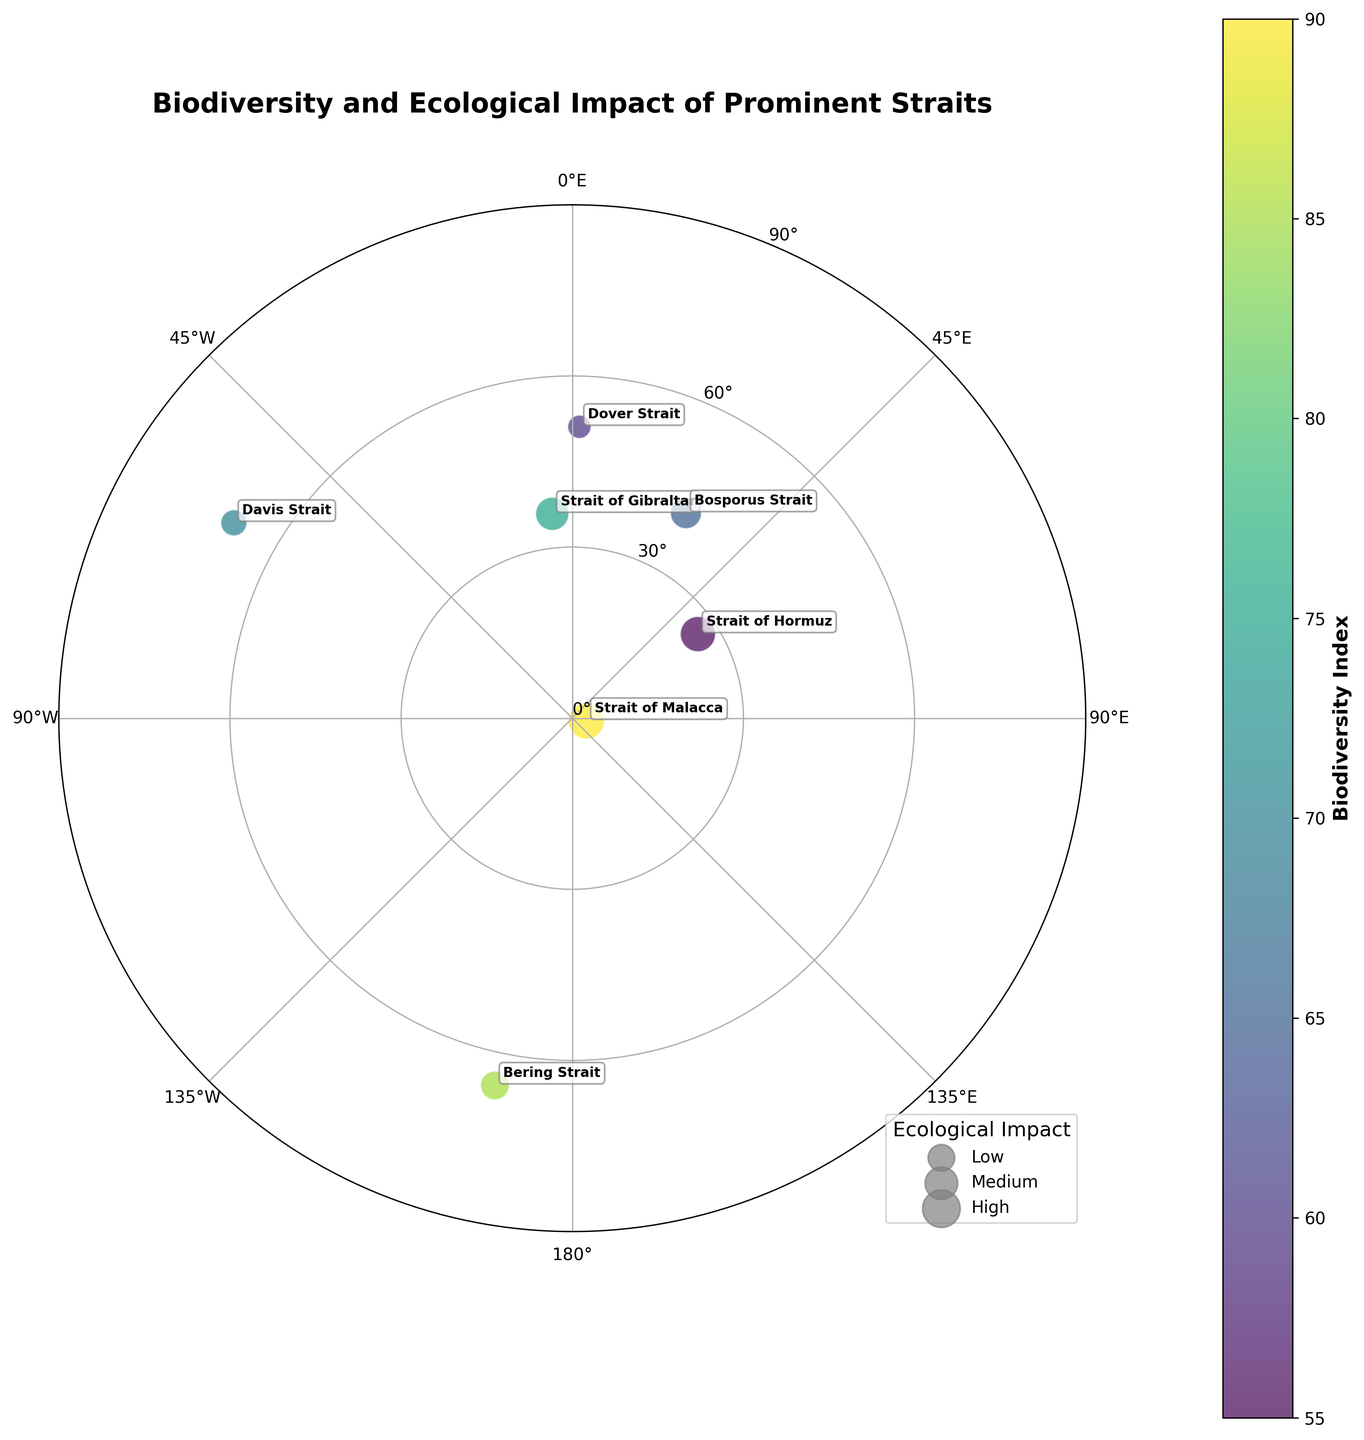What's the title of the figure? The title of the figure is displayed at the top, summarizing the main content it represents.
Answer: Biodiversity and Ecological Impact of Prominent Straits How many straits are displayed in the figure? Count each unique strait labeled in the chart. There are annotations for each strait.
Answer: Eight Which strait has the highest biodiversity index? Look at the color gradient of the points, which represents the biodiversity index based on the color bar. Identify the darkest point.
Answer: Strait of Malacca Which strait has the lowest ecological impact? Check the size of the points, which correlates to ecological impact. Identify the smallest point.
Answer: Dover Strait What is the biodiversity index of the Strait of Hormuz? Identify the position of the Strait of Hormuz and check the corresponding color using the color bar as a reference.
Answer: 55 Which strait lies closest to the North Pole, and what is its latitude? Locate the strait that has the smallest radius from the center, indicating the highest latitude.
Answer: Davis Strait, 68.5° Which strait has a higher longitude, the Bosporus Strait or the Strait of Gibraltar? Identify the position of both straits along the θ-axis and compare their longitudes.
Answer: Bosporus Strait What is the ecological impact of the Torres Strait? Check the size of the point corresponding to the Torres Strait and refer to the legend for ecological impact size reference.
Answer: 85 Which strait has a similar ecological impact to the Strait of Malacca, and how do their biodiversity indexes compare? Find points with similar sizes to the Strait of Malacca and compare their color intensities. The Torres Strait has a comparable size. Compare their biodiversity indexes using color reference.
Answer: Torres Strait; Torres Strait: 80, Strait of Malacca: 90 Arrange the straits from highest to lowest latitude. List all the straits and order based on their distances from the center (maximum latitude at the center).
Answer: Davis Strait, Bering Strait, Bosporus Strait, Dover Strait, Strait of Gibraltar, Torres Strait, Strait of Hormuz, Strait of Malacca 